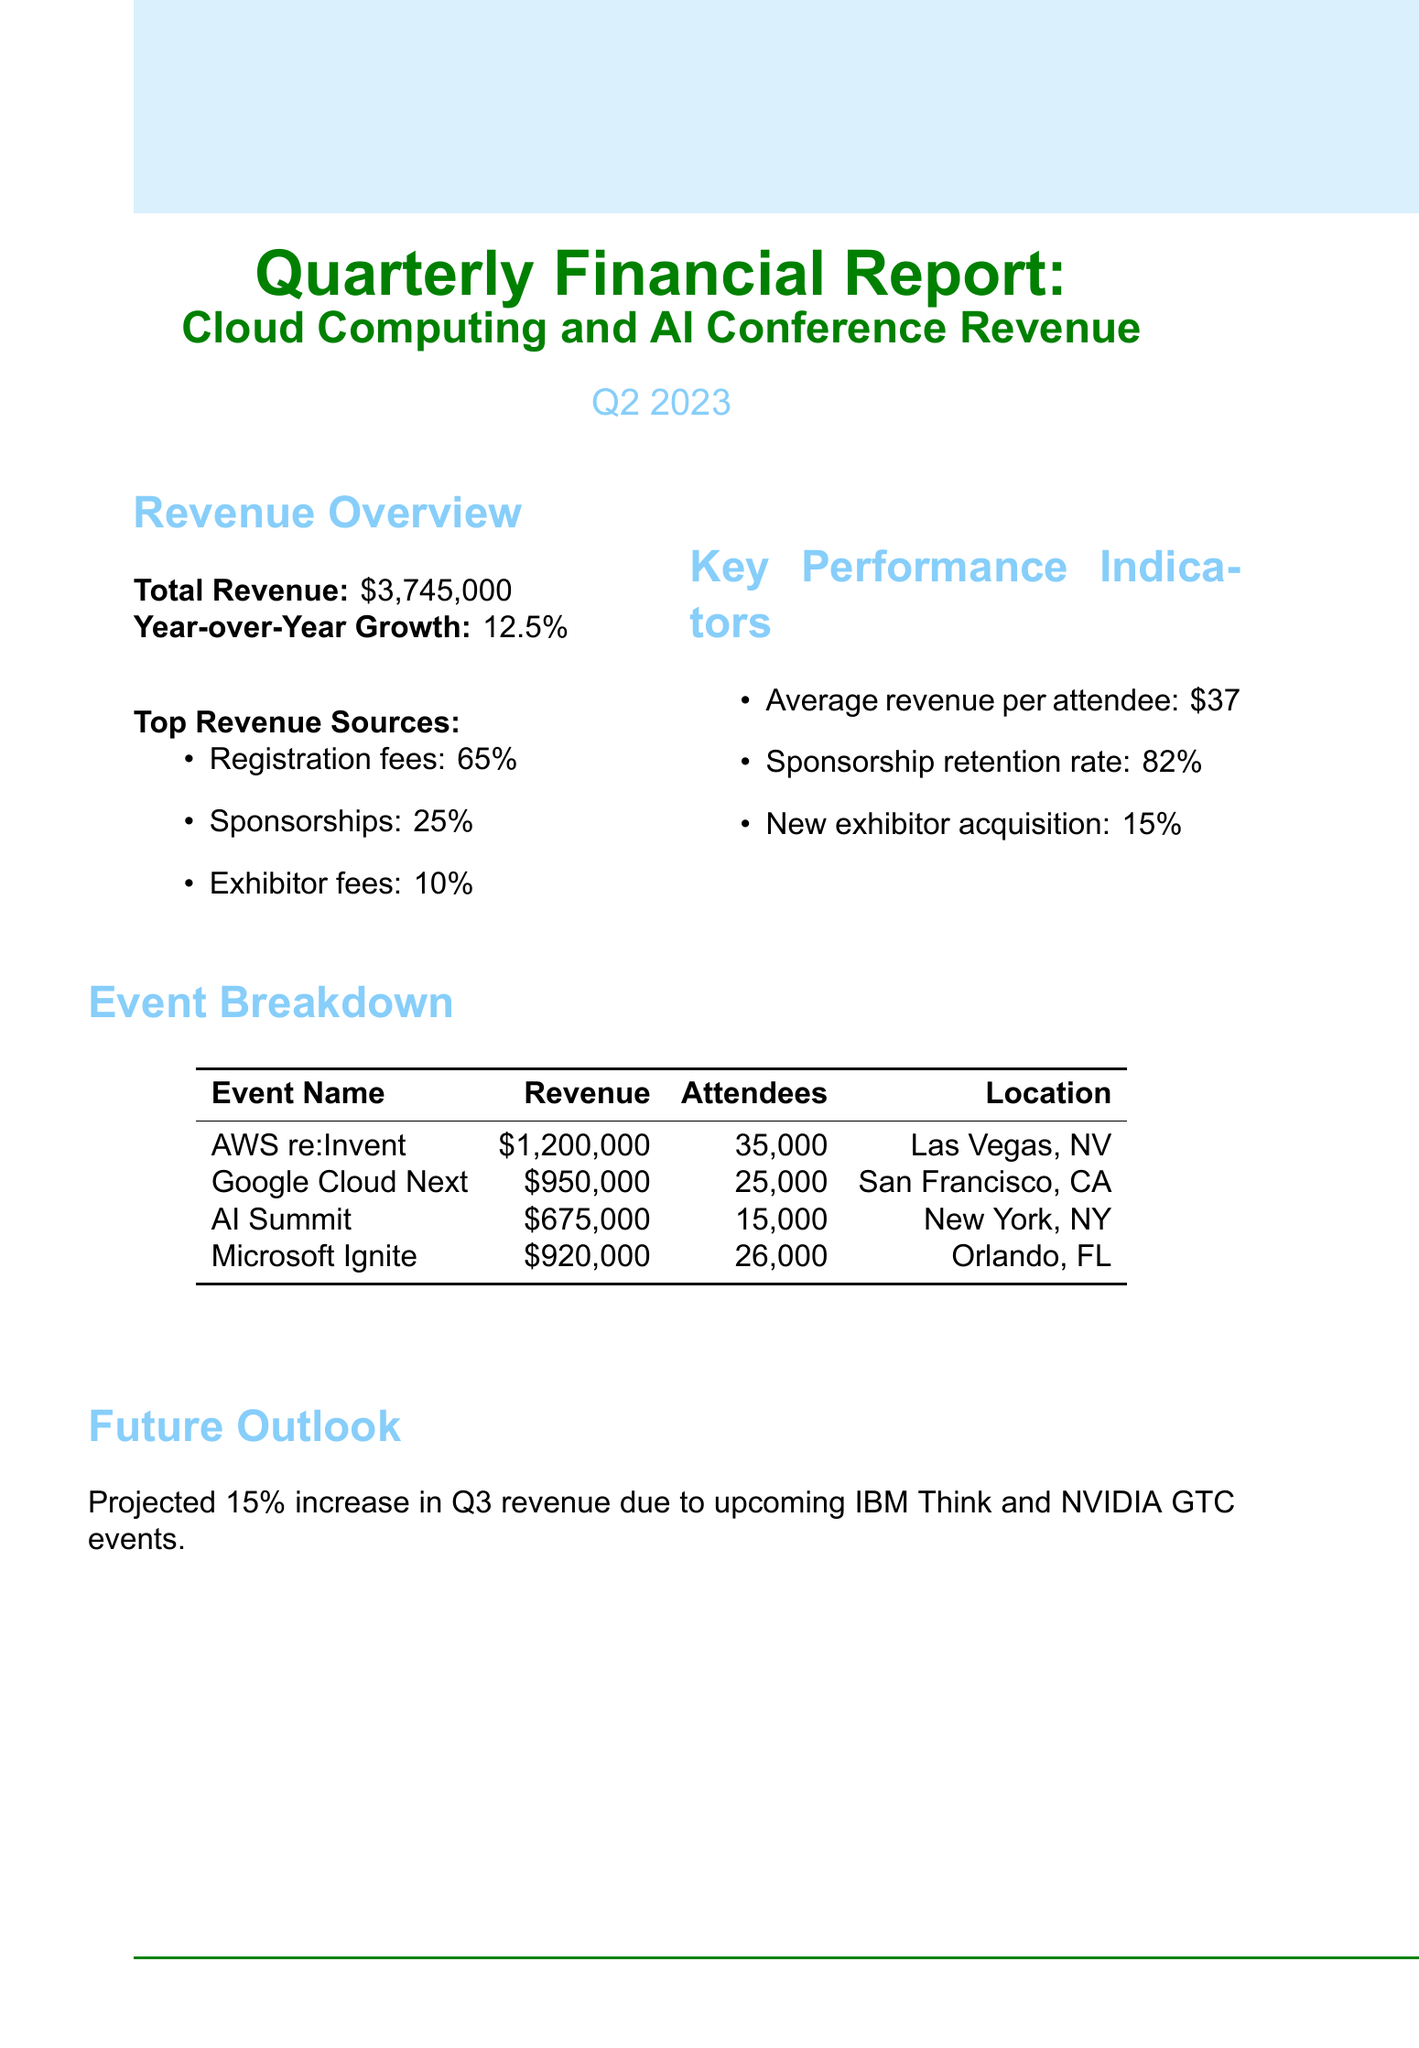What is the total revenue for Q2 2023? The total revenue listed in the document is $3,745,000.
Answer: $3,745,000 How much revenue was generated from AWS re:Invent? The revenue generated from AWS re:Invent is specifically stated in the document as $1,200,000.
Answer: $1,200,000 What is the year-over-year growth percentage? The document states that the year-over-year growth is 12.5%.
Answer: 12.5% What percentage of total revenue comes from registration fees? The report specifies that registration fees account for 65% of the total revenue.
Answer: 65% Which event generated the lowest revenue? The event that generated the lowest revenue is the AI Summit, as detailed in the document.
Answer: AI Summit What is the average revenue per attendee? The document mentions that the average revenue per attendee is $37.
Answer: $37 What is projected for Q3 revenue? The document forecasts a 15% increase in Q3 revenue due to specific upcoming events.
Answer: 15% increase How many attendees were at Google Cloud Next? The document indicates that Google Cloud Next had 25,000 attendees.
Answer: 25,000 What is the sponsorship retention rate? The document notes that the sponsorship retention rate is 82%.
Answer: 82% 